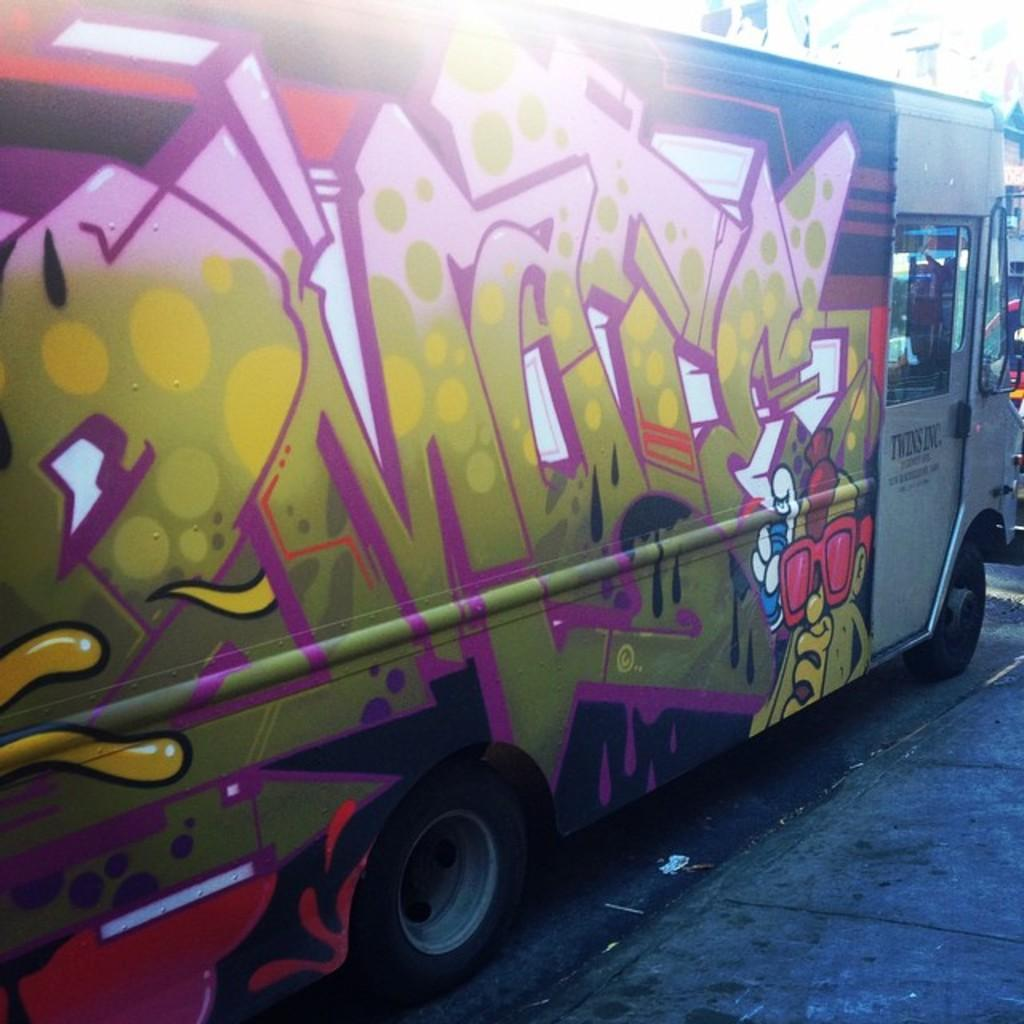What is the main subject of the image? There is a vehicle in the image. Where is the vehicle located? The vehicle is on the road. Can you describe any unique features of the vehicle? The vehicle has a design on it. What type of flower can be seen growing near the vehicle in the image? There is no flower present in the image; it only features a vehicle on the road. 